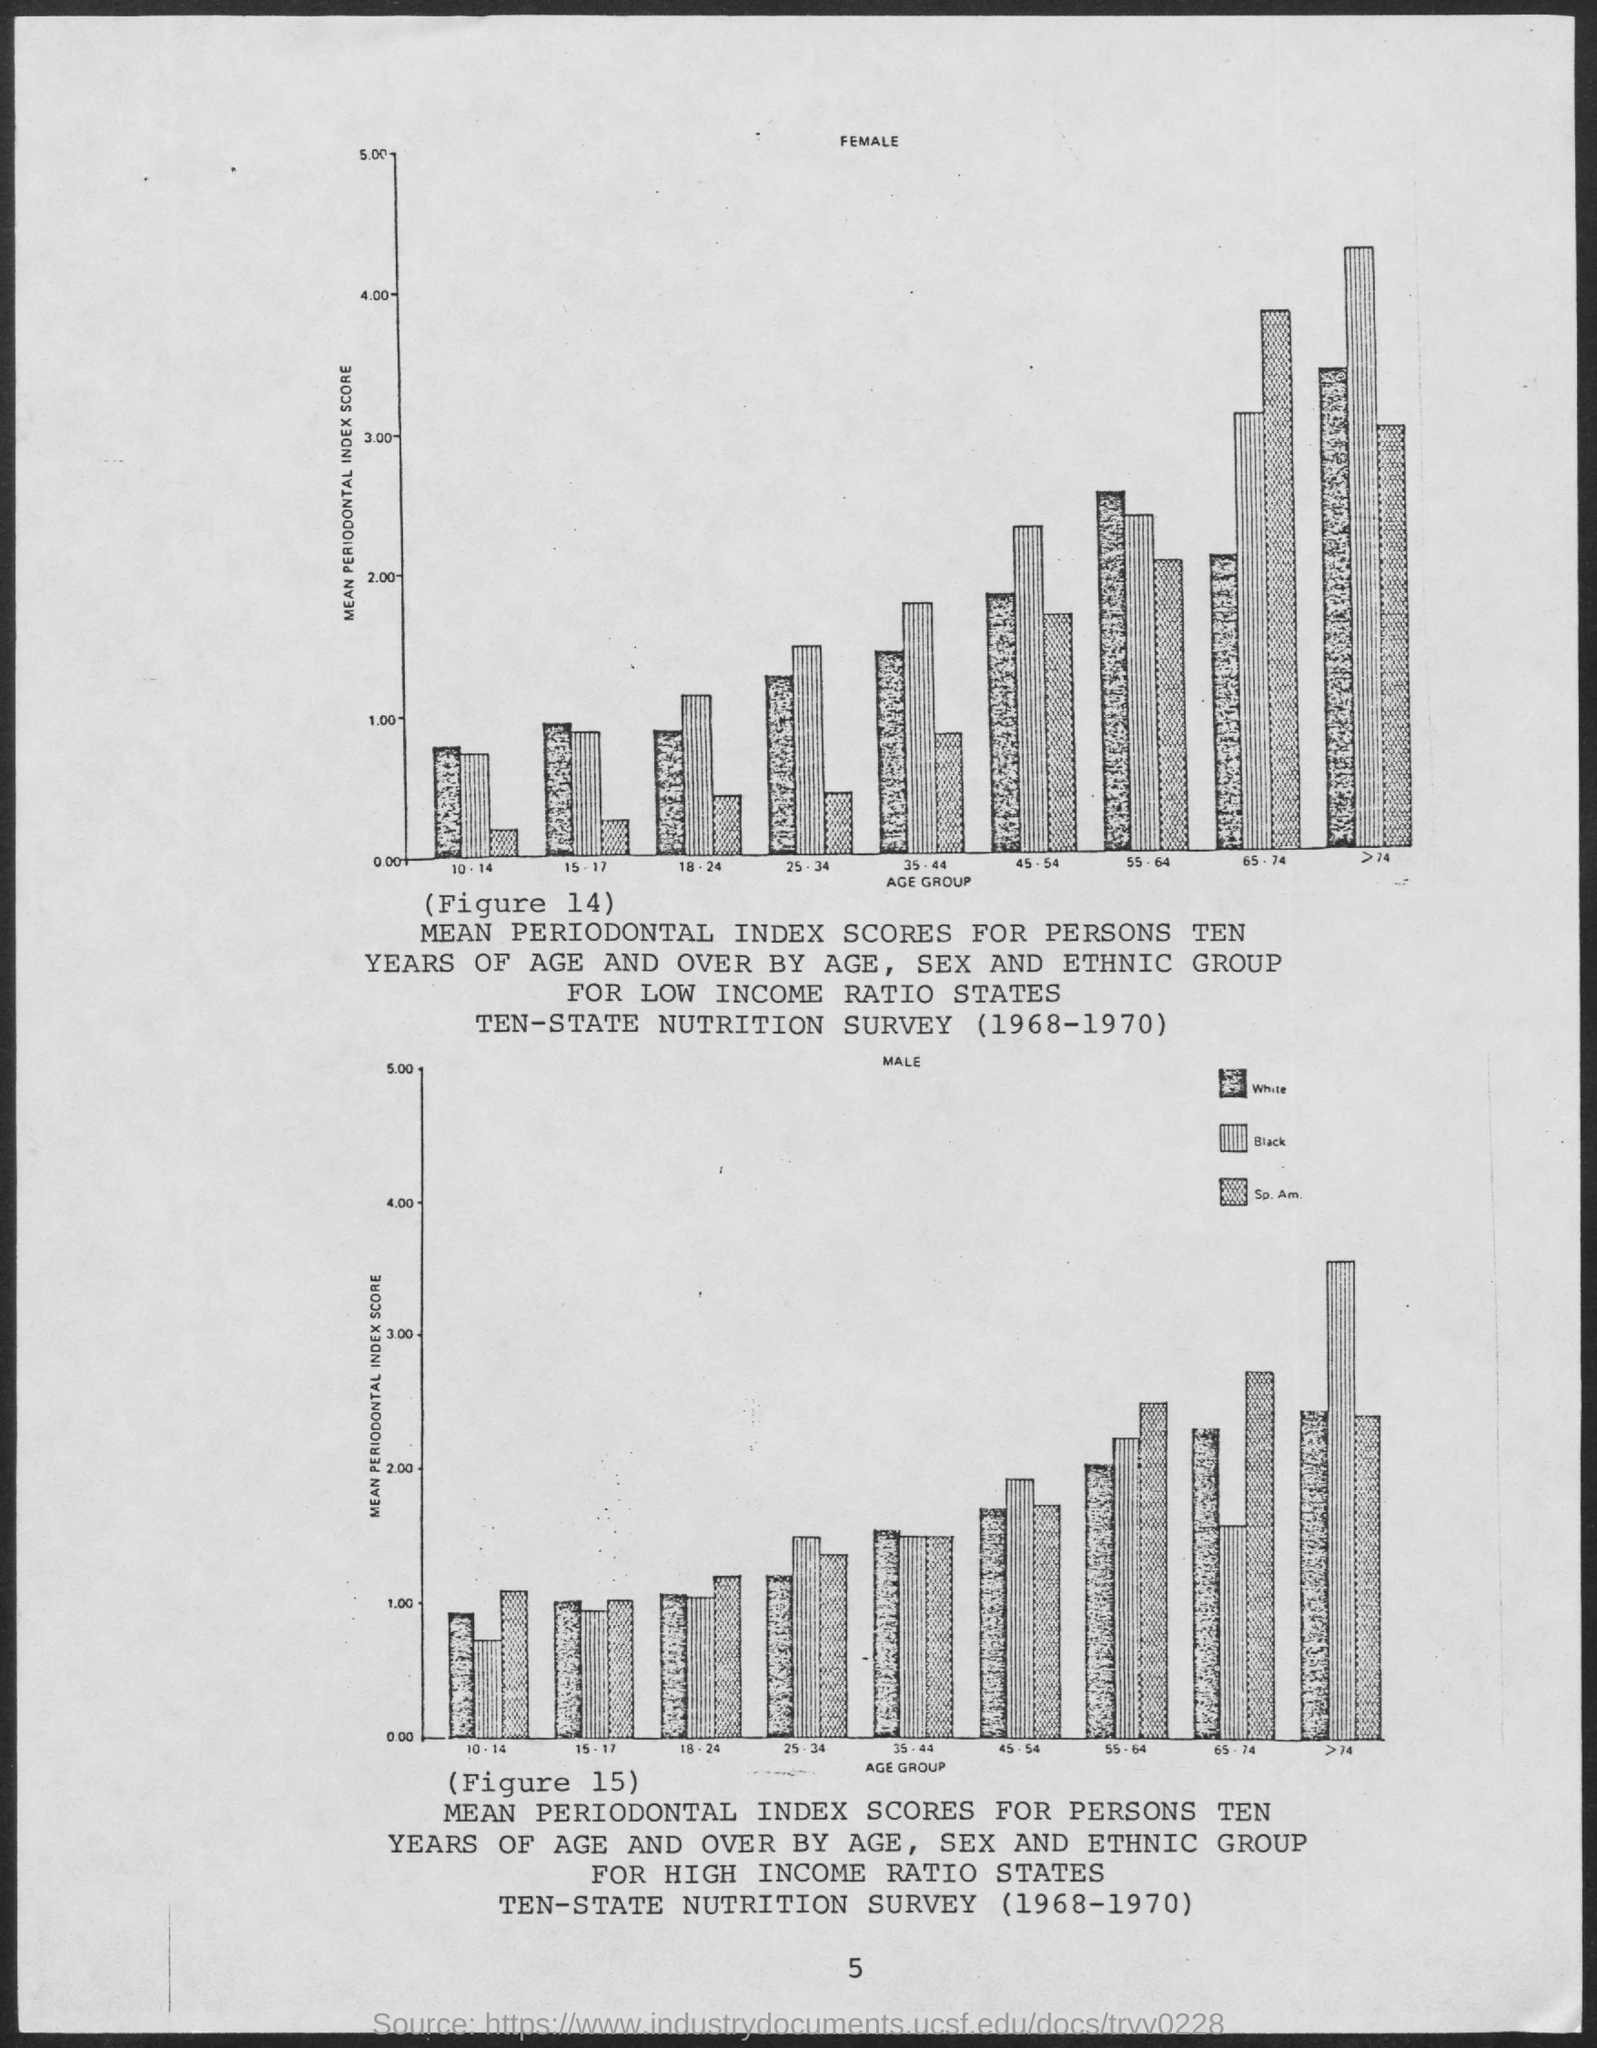Mention a couple of crucial points in this snapshot. The y-axis of both graphs plots the mean periodontal index score. The x-axis of both graphs plots age group. 